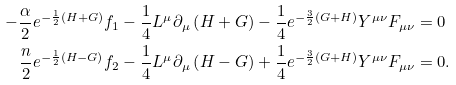<formula> <loc_0><loc_0><loc_500><loc_500>- \frac { \alpha } { 2 } e ^ { - \frac { 1 } { 2 } \left ( H + G \right ) } f _ { 1 } - \frac { 1 } { 4 } L ^ { \mu } \partial _ { \mu } \left ( H + G \right ) - \frac { 1 } { 4 } e ^ { - \frac { 3 } { 2 } \left ( G + H \right ) } Y ^ { \mu \nu } F _ { \mu \nu } & = 0 \\ \frac { n } { 2 } e ^ { - \frac { 1 } { 2 } \left ( H - G \right ) } f _ { 2 } - \frac { 1 } { 4 } L ^ { \mu } \partial _ { \mu } \left ( H - G \right ) + \frac { 1 } { 4 } e ^ { - \frac { 3 } { 2 } \left ( G + H \right ) } Y ^ { \mu \nu } F _ { \mu \nu } & = 0 .</formula> 